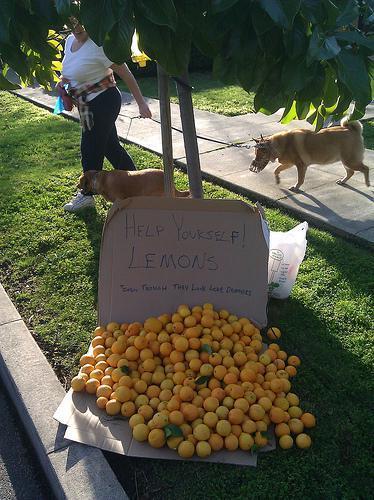How many dogs are in the picture?
Give a very brief answer. 2. 